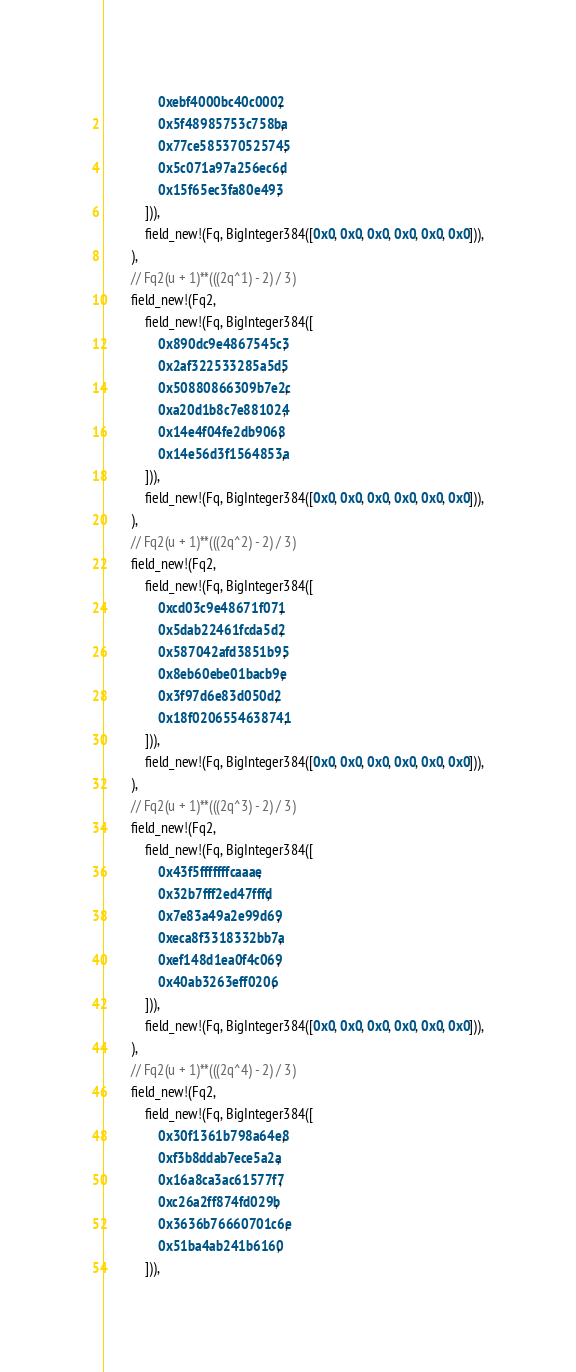Convert code to text. <code><loc_0><loc_0><loc_500><loc_500><_Rust_>                0xebf4000bc40c0002,
                0x5f48985753c758ba,
                0x77ce585370525745,
                0x5c071a97a256ec6d,
                0x15f65ec3fa80e493,
            ])),
            field_new!(Fq, BigInteger384([0x0, 0x0, 0x0, 0x0, 0x0, 0x0])),
        ),
        // Fq2(u + 1)**(((2q^1) - 2) / 3)
        field_new!(Fq2,
            field_new!(Fq, BigInteger384([
                0x890dc9e4867545c3,
                0x2af322533285a5d5,
                0x50880866309b7e2c,
                0xa20d1b8c7e881024,
                0x14e4f04fe2db9068,
                0x14e56d3f1564853a,
            ])),
            field_new!(Fq, BigInteger384([0x0, 0x0, 0x0, 0x0, 0x0, 0x0])),
        ),
        // Fq2(u + 1)**(((2q^2) - 2) / 3)
        field_new!(Fq2,
            field_new!(Fq, BigInteger384([
                0xcd03c9e48671f071,
                0x5dab22461fcda5d2,
                0x587042afd3851b95,
                0x8eb60ebe01bacb9e,
                0x3f97d6e83d050d2,
                0x18f0206554638741,
            ])),
            field_new!(Fq, BigInteger384([0x0, 0x0, 0x0, 0x0, 0x0, 0x0])),
        ),
        // Fq2(u + 1)**(((2q^3) - 2) / 3)
        field_new!(Fq2,
            field_new!(Fq, BigInteger384([
                0x43f5fffffffcaaae,
                0x32b7fff2ed47fffd,
                0x7e83a49a2e99d69,
                0xeca8f3318332bb7a,
                0xef148d1ea0f4c069,
                0x40ab3263eff0206,
            ])),
            field_new!(Fq, BigInteger384([0x0, 0x0, 0x0, 0x0, 0x0, 0x0])),
        ),
        // Fq2(u + 1)**(((2q^4) - 2) / 3)
        field_new!(Fq2,
            field_new!(Fq, BigInteger384([
                0x30f1361b798a64e8,
                0xf3b8ddab7ece5a2a,
                0x16a8ca3ac61577f7,
                0xc26a2ff874fd029b,
                0x3636b76660701c6e,
                0x51ba4ab241b6160,
            ])),</code> 